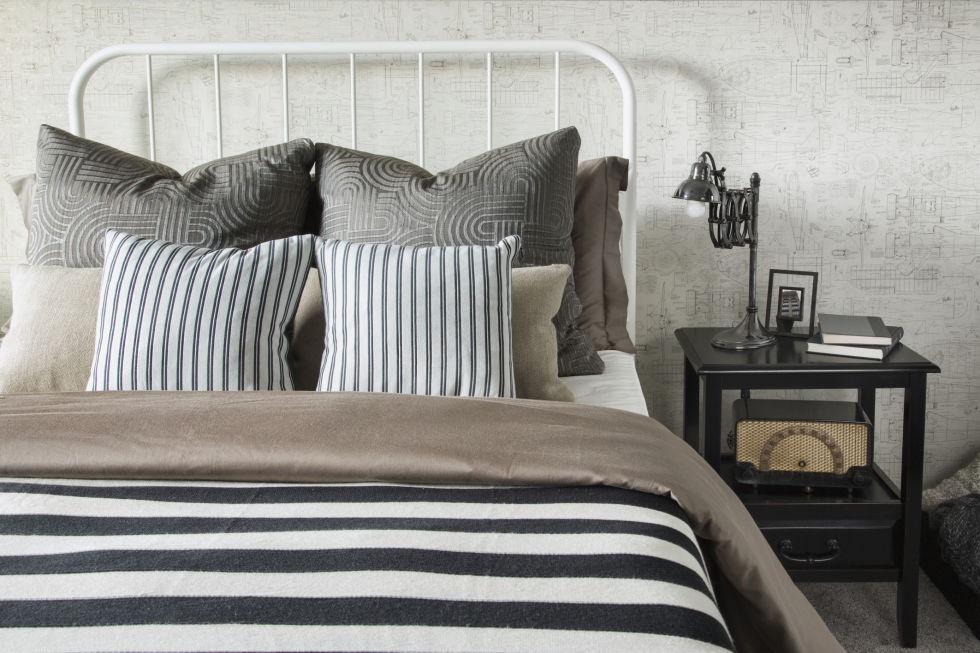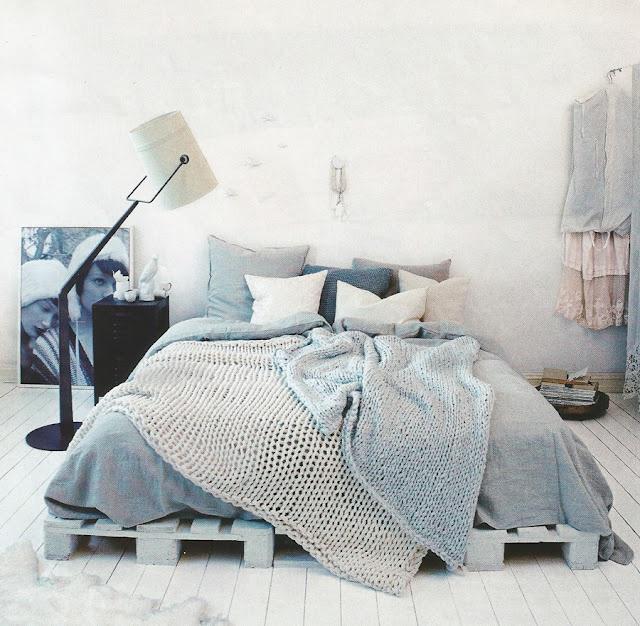The first image is the image on the left, the second image is the image on the right. Given the left and right images, does the statement "One bed has an upholstered headboard." hold true? Answer yes or no. No. 